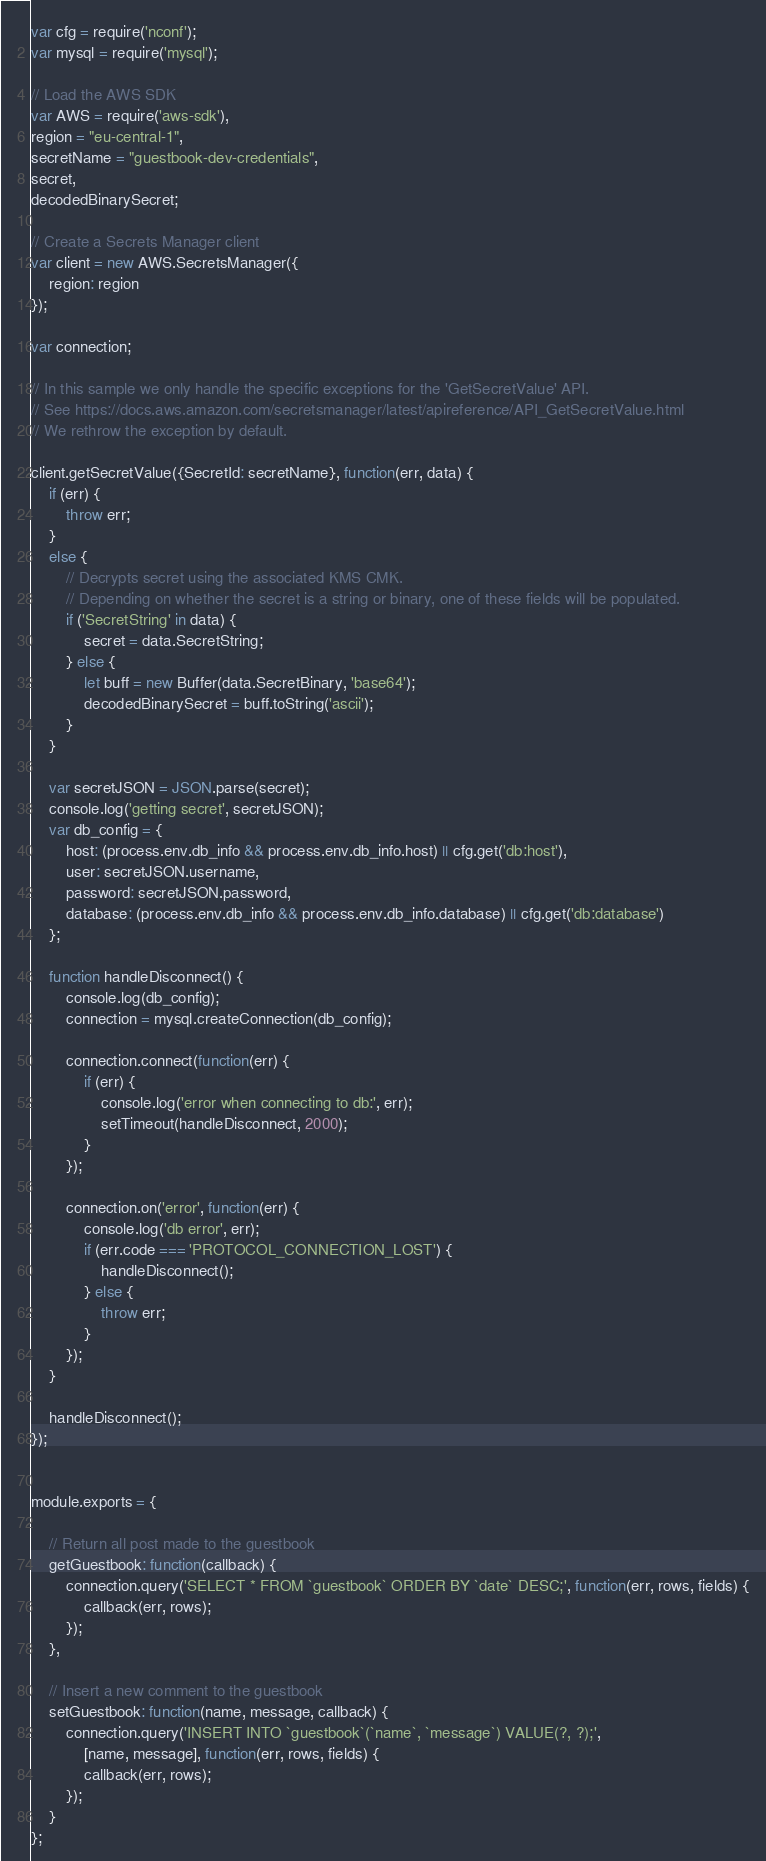Convert code to text. <code><loc_0><loc_0><loc_500><loc_500><_JavaScript_>var cfg = require('nconf');
var mysql = require('mysql');

// Load the AWS SDK
var AWS = require('aws-sdk'),
region = "eu-central-1",
secretName = "guestbook-dev-credentials",
secret,
decodedBinarySecret;

// Create a Secrets Manager client
var client = new AWS.SecretsManager({
    region: region
});

var connection;

// In this sample we only handle the specific exceptions for the 'GetSecretValue' API.
// See https://docs.aws.amazon.com/secretsmanager/latest/apireference/API_GetSecretValue.html
// We rethrow the exception by default.

client.getSecretValue({SecretId: secretName}, function(err, data) {
    if (err) {
        throw err;
    }
    else {
        // Decrypts secret using the associated KMS CMK.
        // Depending on whether the secret is a string or binary, one of these fields will be populated.
        if ('SecretString' in data) {
            secret = data.SecretString;
        } else {
            let buff = new Buffer(data.SecretBinary, 'base64');
            decodedBinarySecret = buff.toString('ascii');
        }
    }

    var secretJSON = JSON.parse(secret);
    console.log('getting secret', secretJSON);
    var db_config = {
        host: (process.env.db_info && process.env.db_info.host) || cfg.get('db:host'),
        user: secretJSON.username,
        password: secretJSON.password,
        database: (process.env.db_info && process.env.db_info.database) || cfg.get('db:database')
    };

    function handleDisconnect() {
        console.log(db_config);
        connection = mysql.createConnection(db_config);

        connection.connect(function(err) {
            if (err) {
                console.log('error when connecting to db:', err);
                setTimeout(handleDisconnect, 2000);
            }
        });

        connection.on('error', function(err) {
            console.log('db error', err);
            if (err.code === 'PROTOCOL_CONNECTION_LOST') {
                handleDisconnect();
            } else {
                throw err;
            }
        });
    }

    handleDisconnect();
});


module.exports = {

    // Return all post made to the guestbook
    getGuestbook: function(callback) {
        connection.query('SELECT * FROM `guestbook` ORDER BY `date` DESC;', function(err, rows, fields) {
            callback(err, rows);
        });
    },

    // Insert a new comment to the guestbook
    setGuestbook: function(name, message, callback) {
        connection.query('INSERT INTO `guestbook`(`name`, `message`) VALUE(?, ?);',
            [name, message], function(err, rows, fields) {
            callback(err, rows);
        });
    }
};
</code> 